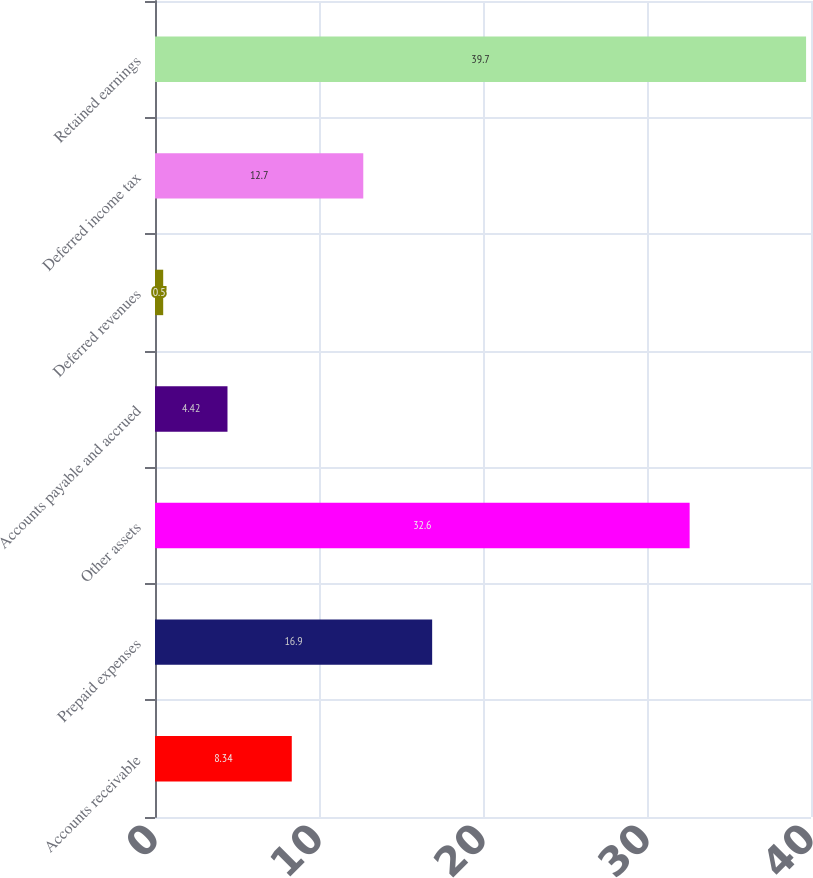Convert chart. <chart><loc_0><loc_0><loc_500><loc_500><bar_chart><fcel>Accounts receivable<fcel>Prepaid expenses<fcel>Other assets<fcel>Accounts payable and accrued<fcel>Deferred revenues<fcel>Deferred income tax<fcel>Retained earnings<nl><fcel>8.34<fcel>16.9<fcel>32.6<fcel>4.42<fcel>0.5<fcel>12.7<fcel>39.7<nl></chart> 